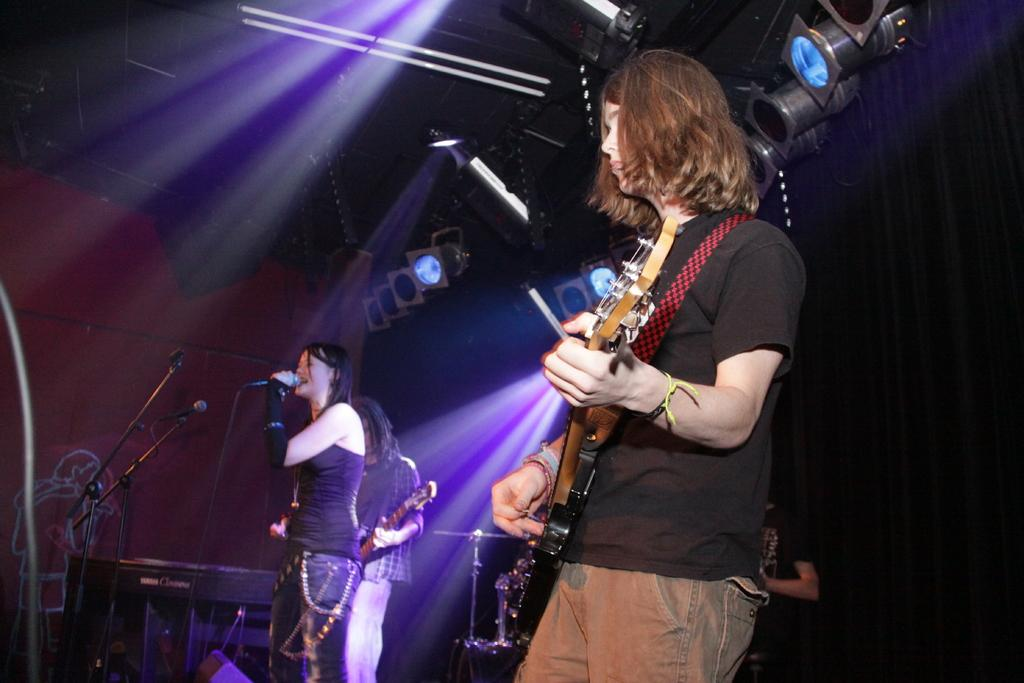What is the woman in the image doing? The woman is singing in the image. What instrument is the woman playing? The woman is playing a guitar. Are there any other musicians in the image? Yes, there is another person playing a guitar in the image. What is the income of the woman in the image? There is no information about the woman's income in the image. How many oranges are visible in the image? There are no oranges present in the image. 